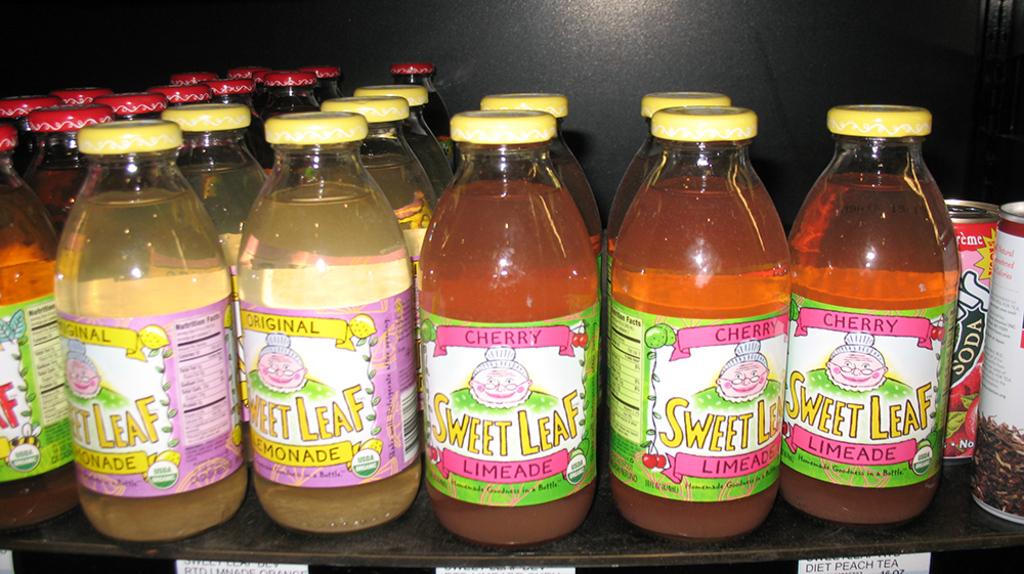What brand are the beverages?
Offer a very short reply. Sweet leaf. What flavor is one of these drinks?
Offer a terse response. Limeade. 